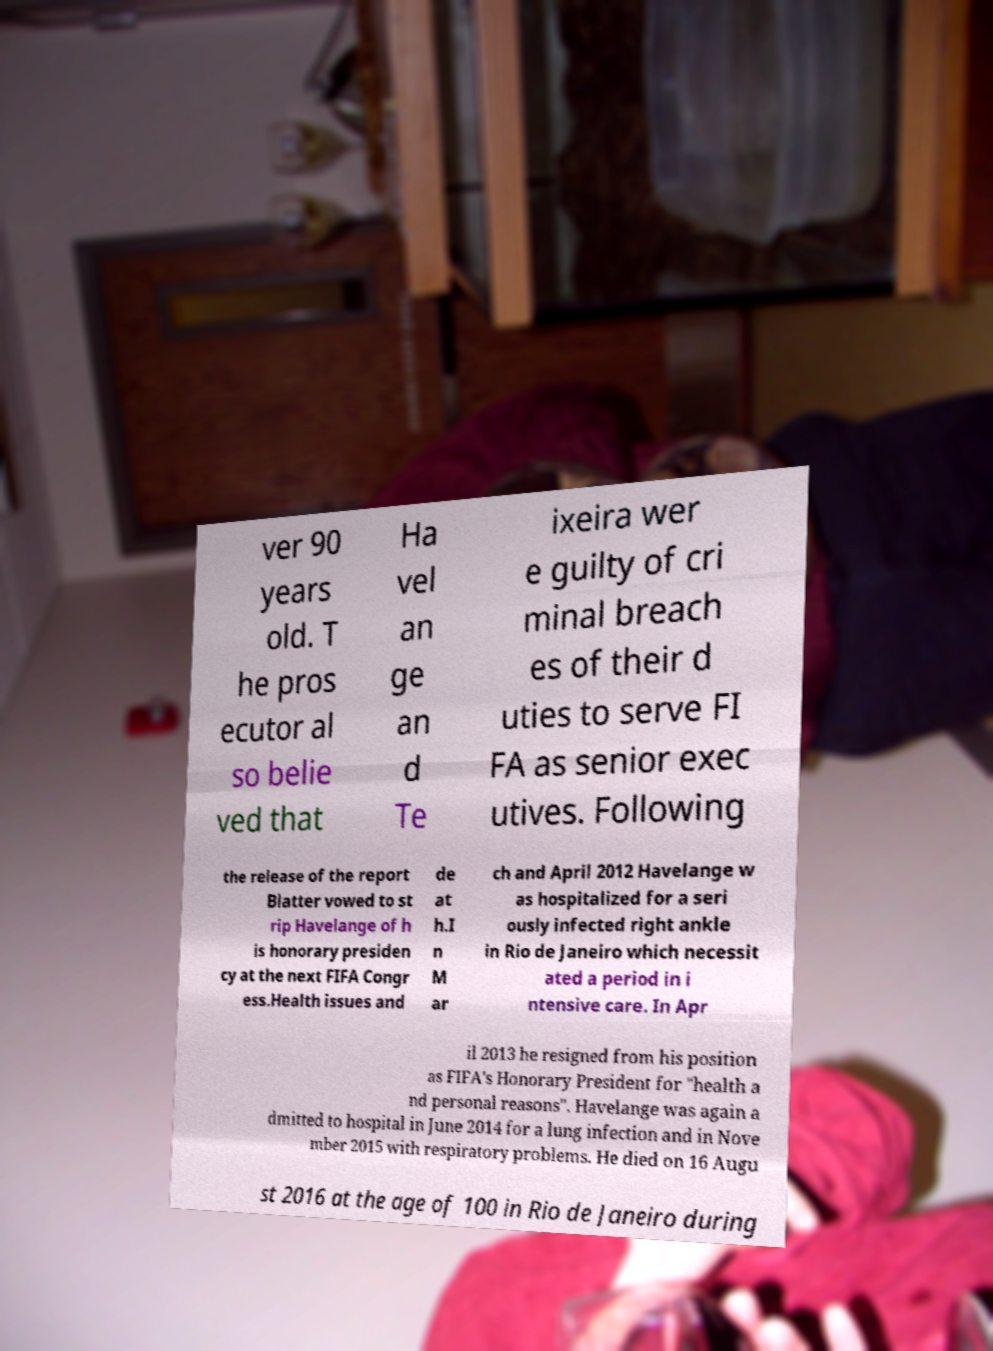Please read and relay the text visible in this image. What does it say? ver 90 years old. T he pros ecutor al so belie ved that Ha vel an ge an d Te ixeira wer e guilty of cri minal breach es of their d uties to serve FI FA as senior exec utives. Following the release of the report Blatter vowed to st rip Havelange of h is honorary presiden cy at the next FIFA Congr ess.Health issues and de at h.I n M ar ch and April 2012 Havelange w as hospitalized for a seri ously infected right ankle in Rio de Janeiro which necessit ated a period in i ntensive care. In Apr il 2013 he resigned from his position as FIFA's Honorary President for "health a nd personal reasons". Havelange was again a dmitted to hospital in June 2014 for a lung infection and in Nove mber 2015 with respiratory problems. He died on 16 Augu st 2016 at the age of 100 in Rio de Janeiro during 